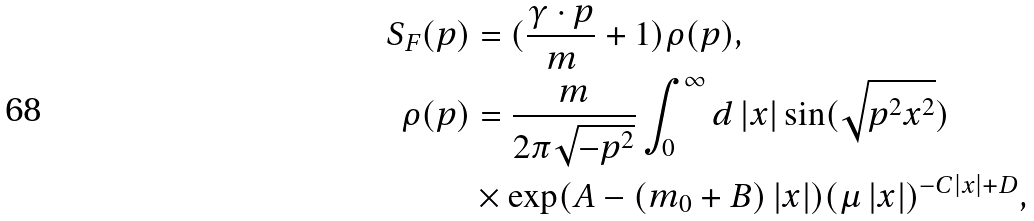Convert formula to latex. <formula><loc_0><loc_0><loc_500><loc_500>S _ { F } ( p ) & = ( \frac { \gamma \cdot p } { m } + 1 ) \rho ( p ) , \\ \rho ( p ) & = \frac { m } { 2 \pi \sqrt { - p ^ { 2 } } } \int _ { 0 } ^ { \infty } d \left | x \right | \sin ( \sqrt { p ^ { 2 } x ^ { 2 } } ) \\ & \times \exp ( A - ( m _ { 0 } + B ) \left | x \right | ) ( \mu \left | x \right | ) ^ { - C \left | x \right | + D } ,</formula> 